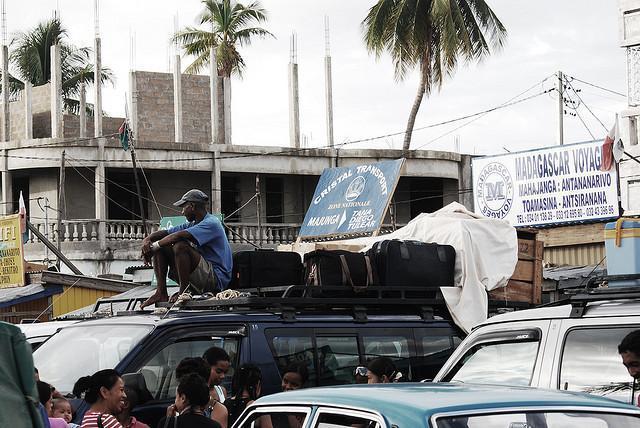How many palm trees are pictured?
Give a very brief answer. 3. How many suitcases can you see?
Give a very brief answer. 3. How many cars are there?
Give a very brief answer. 3. How many people can be seen?
Give a very brief answer. 3. How many dog ears are shown?
Give a very brief answer. 0. 